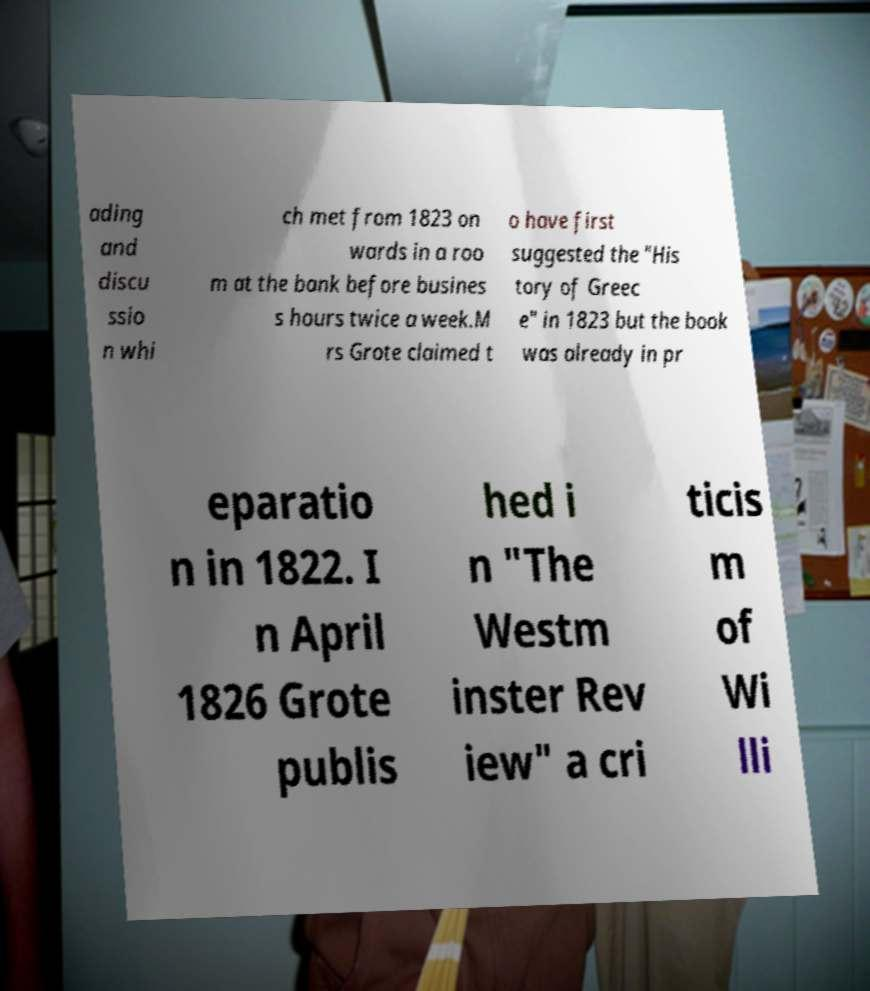I need the written content from this picture converted into text. Can you do that? ading and discu ssio n whi ch met from 1823 on wards in a roo m at the bank before busines s hours twice a week.M rs Grote claimed t o have first suggested the "His tory of Greec e" in 1823 but the book was already in pr eparatio n in 1822. I n April 1826 Grote publis hed i n "The Westm inster Rev iew" a cri ticis m of Wi lli 